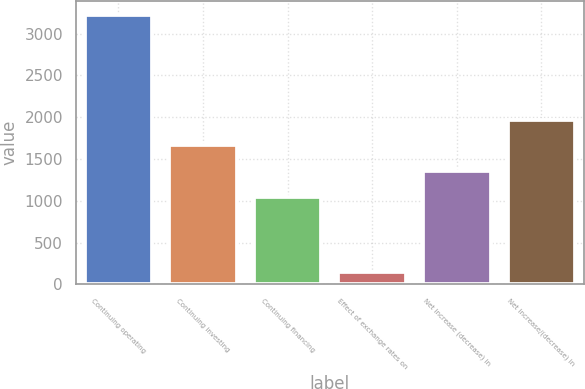Convert chart to OTSL. <chart><loc_0><loc_0><loc_500><loc_500><bar_chart><fcel>Continuing operating<fcel>Continuing investing<fcel>Continuing financing<fcel>Effect of exchange rates on<fcel>Net increase (decrease) in<fcel>Net increase/(decrease) in<nl><fcel>3228<fcel>1663<fcel>1047<fcel>148<fcel>1355<fcel>1971<nl></chart> 